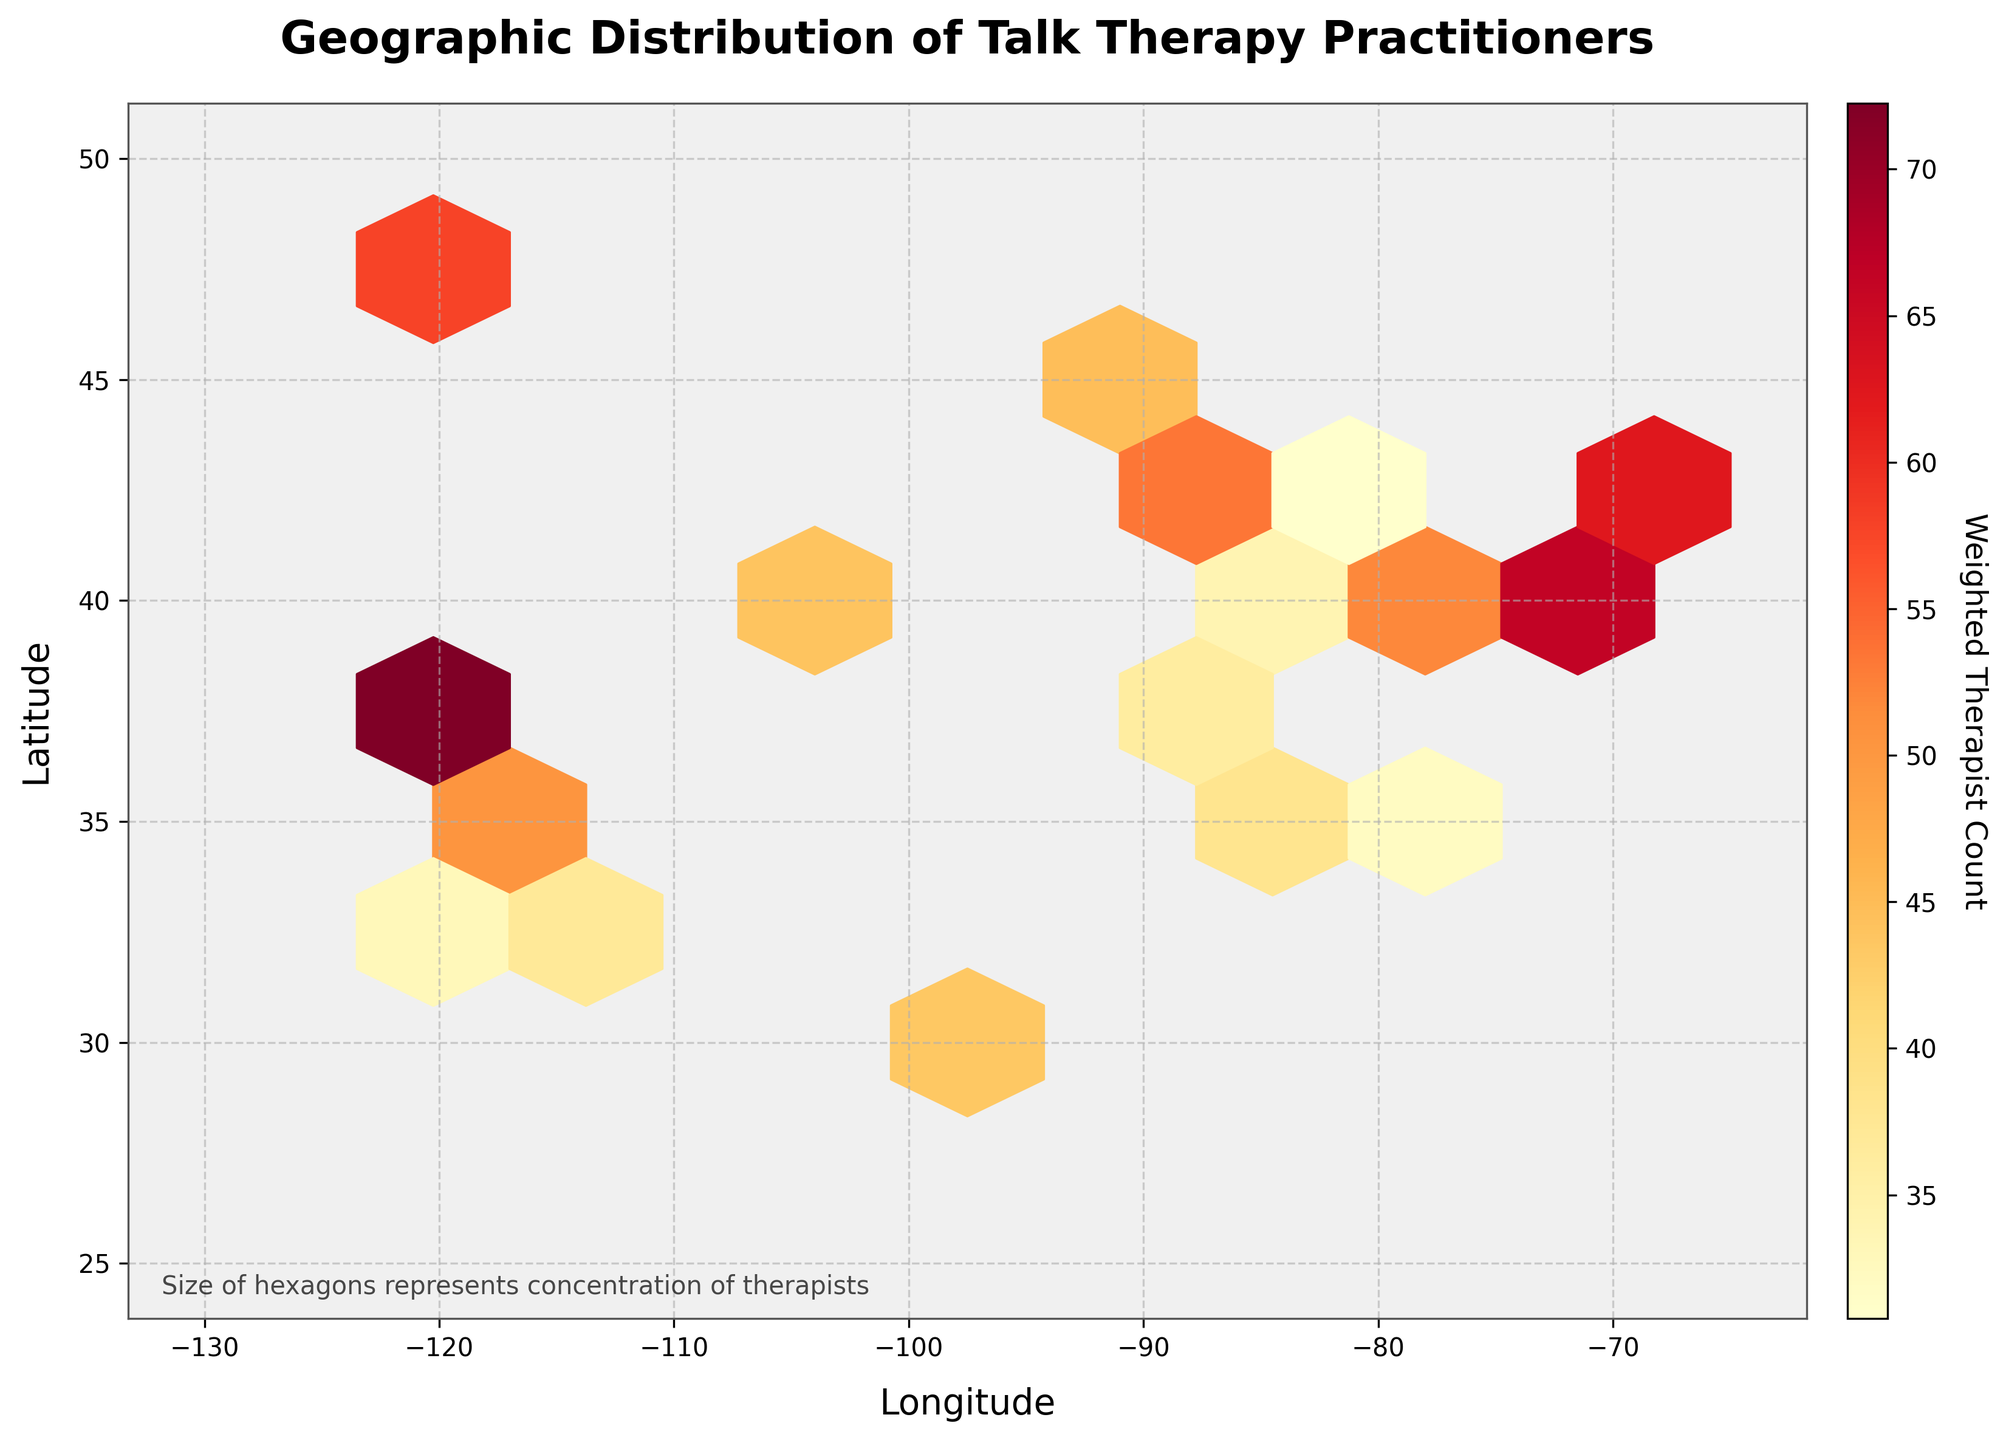What's the title of the figure? The title is the largest text usually located at the top of the figure. It generally summarizes the content and purpose of the plot. Referring to the provided data, the title is "Geographic Distribution of Talk Therapy Practitioners".
Answer: Geographic Distribution of Talk Therapy Practitioners What is the color map used in the hexbin plot? The color map represents the weighted therapist count, and it is generally specified in the plot's color legend or visually noticeable through the color gradient used in the hexagons. The color map used is 'YlOrRd', which is a gradient from yellow to red.
Answer: Yellow to Red Which region has the highest concentration of talk therapy practitioners? To determine this, look for the darkest or most densely colored hexagon on the plot which indicates the highest weighted therapist count. The highest concentration appears around the region corresponding to New York City (longitude -74.0060, latitude 40.7128).
Answer: New York City area Are there more talk therapy practitioners on the East Coast or the West Coast? Compare the density of hexagons on the respective coasts. The East Coast, particularly around New York City and Boston, has a higher concentration of talk therapy practitioners than the West Coast regions.
Answer: East Coast Which city has a higher weighted therapist count, Los Angeles or Chicago? Evaluate the color intensity of the hexagons around Los Angeles and Chicago. Los Angeles (longitude -118.2437, latitude 34.0522) appears to have a darker hexagon than Chicago (longitude -87.6298, latitude 41.8781), indicating a higher weighted therapist count.
Answer: Los Angeles What does the color bar represent in the figure? The color bar typically provides a scale for interpreting the color gradient of the hexagons. Here it indicates the 'Weighted Therapist Count', which is the product of the number of therapists and the proportion focusing on talk therapy.
Answer: Weighted Therapist Count How does the geographical distribution of talk therapy practitioners in Seattle compare to Houston? Assess the relative darkness of hexagons near Seattle (longitude -122.3321, latitude 47.6062) and Houston (longitude -95.3698, latitude 29.7604). The hexagon near Seattle is darker, indicating a higher weighted therapist count than Houston.
Answer: Seattle has a higher weighted count Is there a notable concentration of talk therapy practitioners in the Midwest? Analyze the plot for noticeable hexagons in the Midwest region. While there are some hexagons, indicating presence, areas like Chicago and Minneapolis have relatively lighter hexagons compared to coastal cities.
Answer: Less concentration compared to coasts 